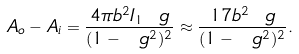<formula> <loc_0><loc_0><loc_500><loc_500>A _ { o } - A _ { i } = \frac { 4 \pi b ^ { 2 } I _ { 1 } \ g } { ( 1 - \ g ^ { 2 } ) ^ { 2 } } \approx \frac { 1 7 b ^ { 2 } \ g } { ( 1 - \ g ^ { 2 } ) ^ { 2 } } .</formula> 